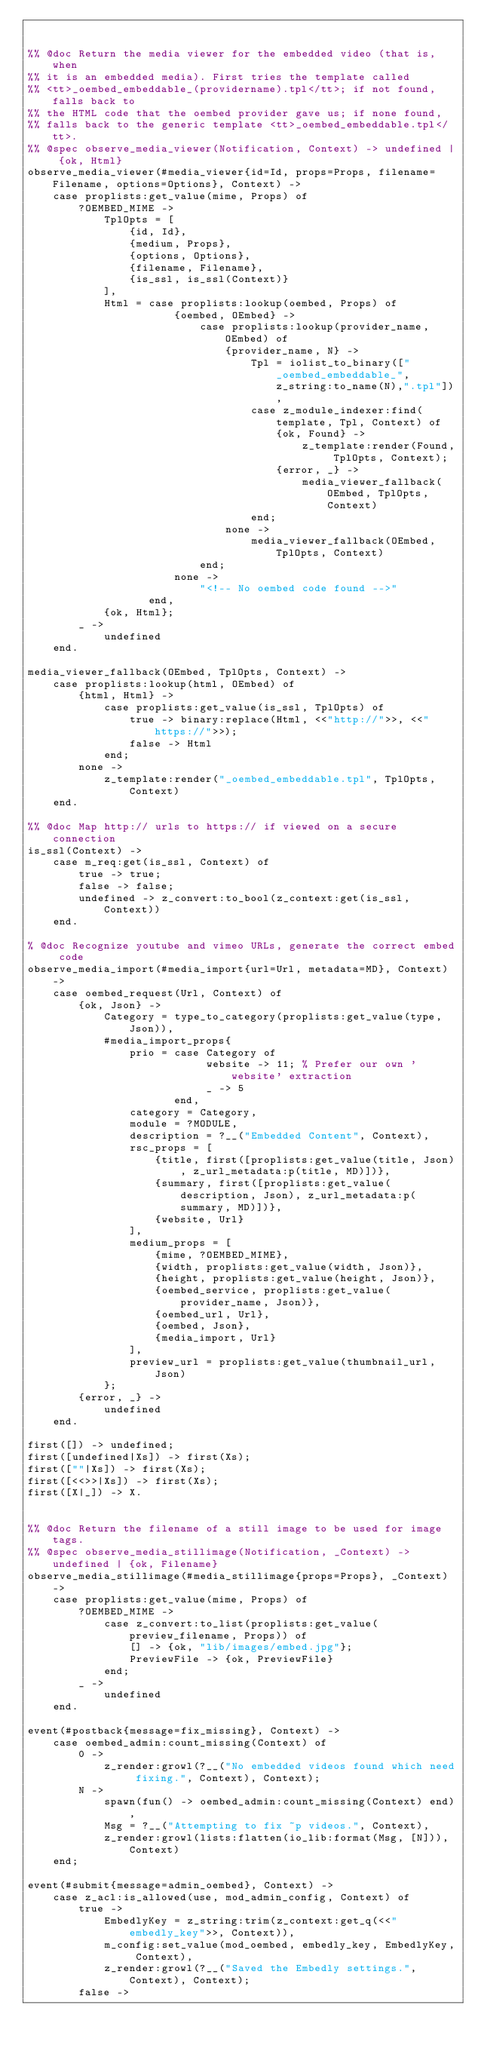<code> <loc_0><loc_0><loc_500><loc_500><_Erlang_>

%% @doc Return the media viewer for the embedded video (that is, when
%% it is an embedded media). First tries the template called
%% <tt>_oembed_embeddable_(providername).tpl</tt>; if not found, falls back to
%% the HTML code that the oembed provider gave us; if none found,
%% falls back to the generic template <tt>_oembed_embeddable.tpl</tt>.
%% @spec observe_media_viewer(Notification, Context) -> undefined | {ok, Html}
observe_media_viewer(#media_viewer{id=Id, props=Props, filename=Filename, options=Options}, Context) ->
    case proplists:get_value(mime, Props) of
        ?OEMBED_MIME ->
            TplOpts = [
                {id, Id},
                {medium, Props},
                {options, Options},
                {filename, Filename},
                {is_ssl, is_ssl(Context)}
            ],
            Html = case proplists:lookup(oembed, Props) of
                       {oembed, OEmbed} ->
                           case proplists:lookup(provider_name, OEmbed) of
                               {provider_name, N} ->
                                   Tpl = iolist_to_binary(["_oembed_embeddable_",z_string:to_name(N),".tpl"]),
                                   case z_module_indexer:find(template, Tpl, Context) of
                                       {ok, Found} ->
                                           z_template:render(Found, TplOpts, Context);
                                       {error, _} ->
                                           media_viewer_fallback(OEmbed, TplOpts, Context)
                                   end;
                               none ->
                                   media_viewer_fallback(OEmbed, TplOpts, Context)
                           end;
                       none ->
                           "<!-- No oembed code found -->"
                   end,
            {ok, Html};
        _ ->
            undefined
    end.

media_viewer_fallback(OEmbed, TplOpts, Context) ->
    case proplists:lookup(html, OEmbed) of
        {html, Html} ->
            case proplists:get_value(is_ssl, TplOpts) of
                true -> binary:replace(Html, <<"http://">>, <<"https://">>);
                false -> Html
            end;
        none ->
            z_template:render("_oembed_embeddable.tpl", TplOpts, Context)
    end.

%% @doc Map http:// urls to https:// if viewed on a secure connection
is_ssl(Context) ->
    case m_req:get(is_ssl, Context) of
        true -> true;
        false -> false;
        undefined -> z_convert:to_bool(z_context:get(is_ssl, Context))
    end.

% @doc Recognize youtube and vimeo URLs, generate the correct embed code
observe_media_import(#media_import{url=Url, metadata=MD}, Context) ->
    case oembed_request(Url, Context) of
        {ok, Json} ->
            Category = type_to_category(proplists:get_value(type, Json)),
            #media_import_props{
                prio = case Category of
                            website -> 11; % Prefer our own 'website' extraction
                            _ -> 5
                       end,
                category = Category,
                module = ?MODULE,
                description = ?__("Embedded Content", Context),
                rsc_props = [
                    {title, first([proplists:get_value(title, Json), z_url_metadata:p(title, MD)])},
                    {summary, first([proplists:get_value(description, Json), z_url_metadata:p(summary, MD)])},
                    {website, Url}
                ],
                medium_props = [
                    {mime, ?OEMBED_MIME},
                    {width, proplists:get_value(width, Json)},
                    {height, proplists:get_value(height, Json)},
                    {oembed_service, proplists:get_value(provider_name, Json)},
                    {oembed_url, Url},
                    {oembed, Json},
                    {media_import, Url}
                ],
                preview_url = proplists:get_value(thumbnail_url, Json)
            };
        {error, _} ->
            undefined
    end.

first([]) -> undefined;
first([undefined|Xs]) -> first(Xs);
first([""|Xs]) -> first(Xs);
first([<<>>|Xs]) -> first(Xs);
first([X|_]) -> X.


%% @doc Return the filename of a still image to be used for image tags.
%% @spec observe_media_stillimage(Notification, _Context) -> undefined | {ok, Filename}
observe_media_stillimage(#media_stillimage{props=Props}, _Context) ->
    case proplists:get_value(mime, Props) of
        ?OEMBED_MIME ->
            case z_convert:to_list(proplists:get_value(preview_filename, Props)) of
                [] -> {ok, "lib/images/embed.jpg"};
                PreviewFile -> {ok, PreviewFile}
            end;
        _ ->
            undefined
    end.

event(#postback{message=fix_missing}, Context) ->
    case oembed_admin:count_missing(Context) of
        0 ->
            z_render:growl(?__("No embedded videos found which need fixing.", Context), Context);
        N ->
            spawn(fun() -> oembed_admin:count_missing(Context) end),
            Msg = ?__("Attempting to fix ~p videos.", Context),
            z_render:growl(lists:flatten(io_lib:format(Msg, [N])), Context)
    end;

event(#submit{message=admin_oembed}, Context) ->
    case z_acl:is_allowed(use, mod_admin_config, Context) of
        true ->
            EmbedlyKey = z_string:trim(z_context:get_q(<<"embedly_key">>, Context)),
            m_config:set_value(mod_oembed, embedly_key, EmbedlyKey, Context),
            z_render:growl(?__("Saved the Embedly settings.", Context), Context);
        false -></code> 